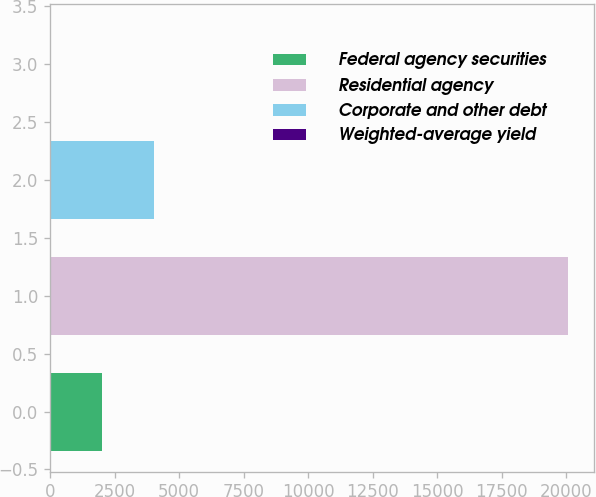<chart> <loc_0><loc_0><loc_500><loc_500><bar_chart><fcel>Federal agency securities<fcel>Residential agency<fcel>Corporate and other debt<fcel>Weighted-average yield<nl><fcel>2009.5<fcel>20072<fcel>4016.44<fcel>2.56<nl></chart> 